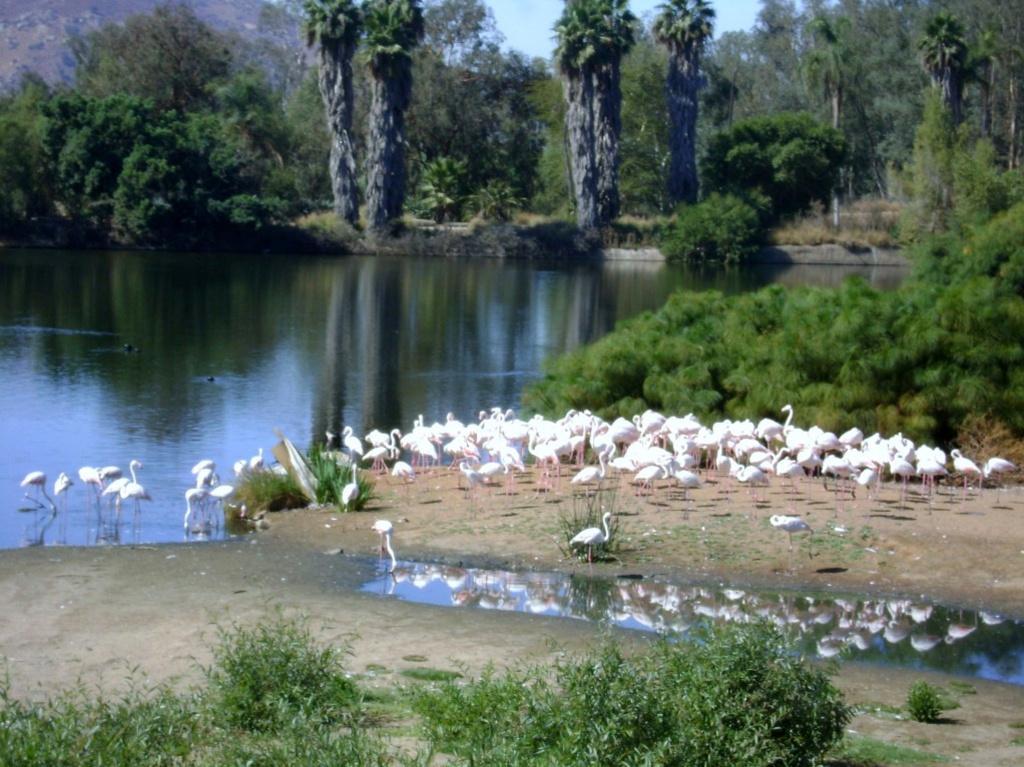Can you describe this image briefly? In this image I can see there are many ducks, some are on the ground, some are on the water. There is water and at the back there are many trees. 